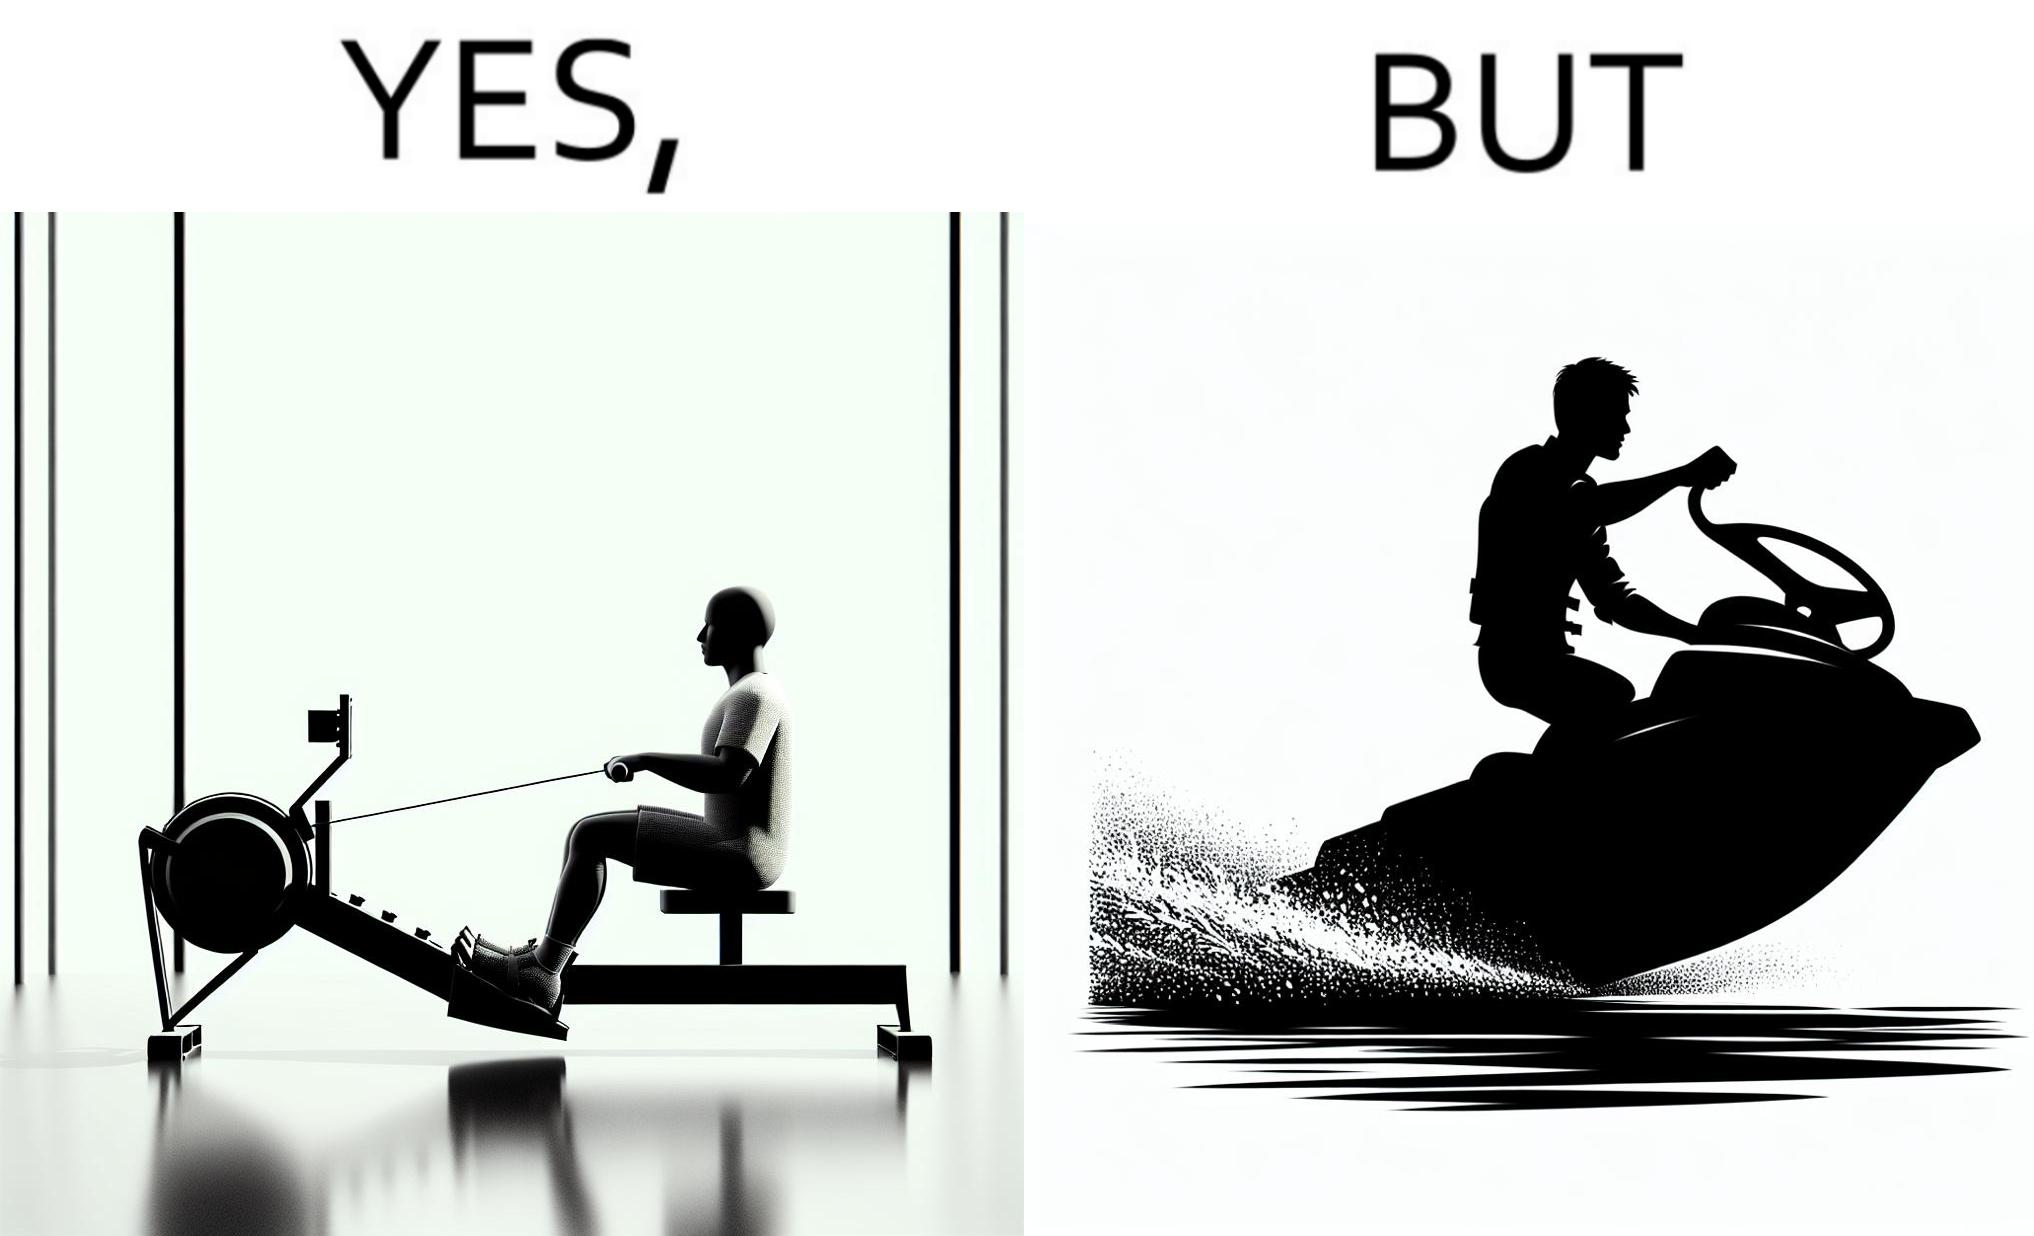Would you classify this image as satirical? Yes, this image is satirical. 